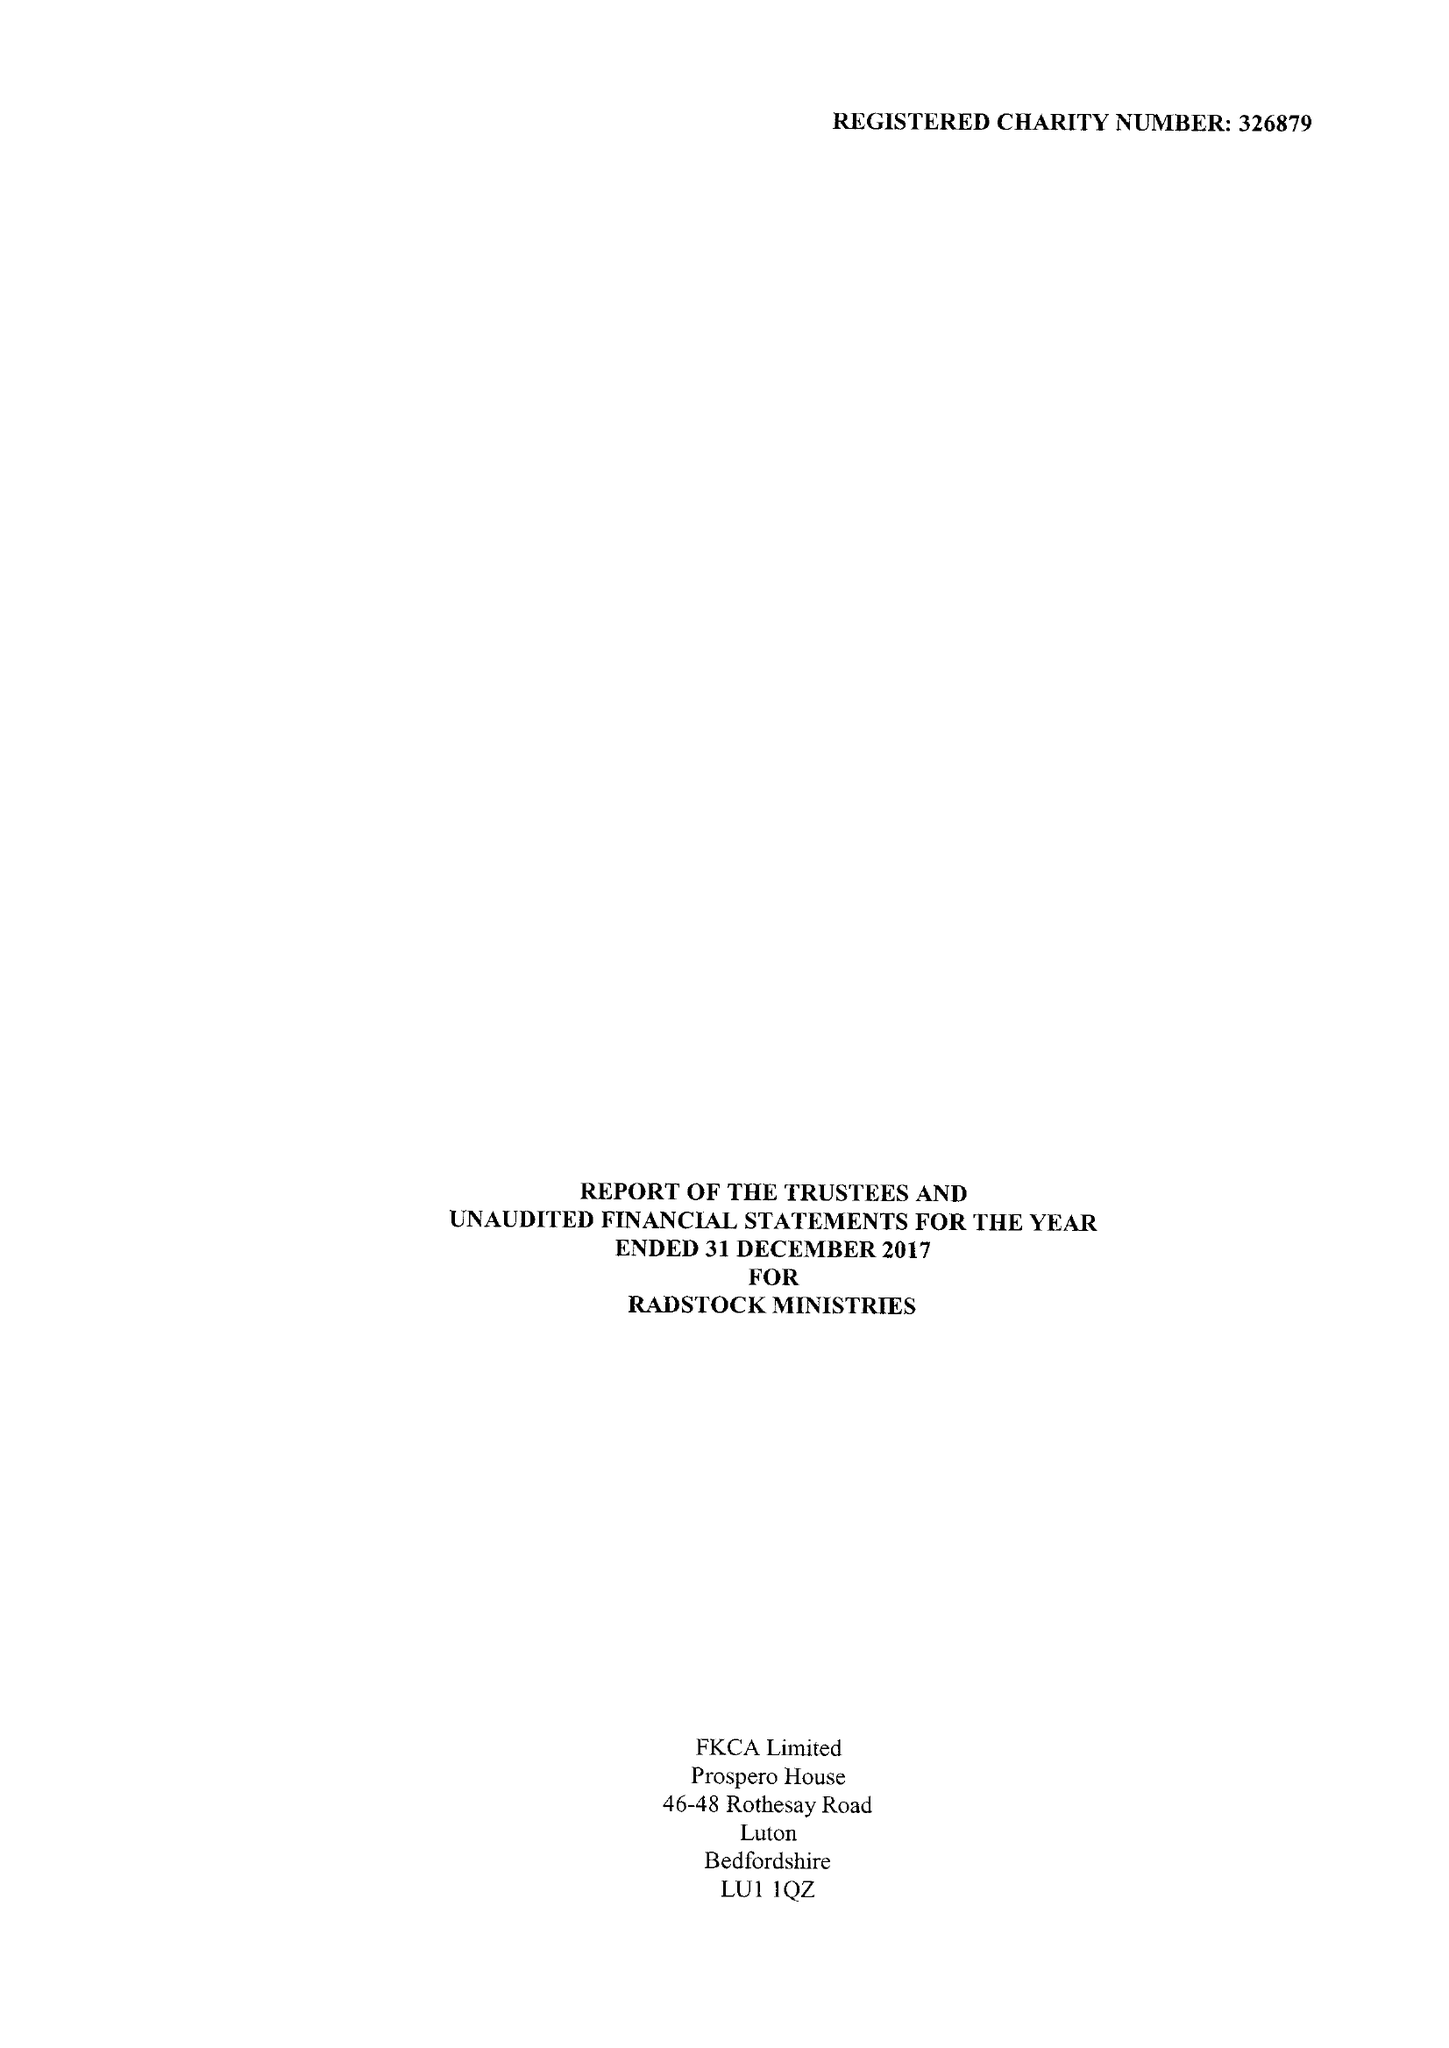What is the value for the address__post_town?
Answer the question using a single word or phrase. LUTON 